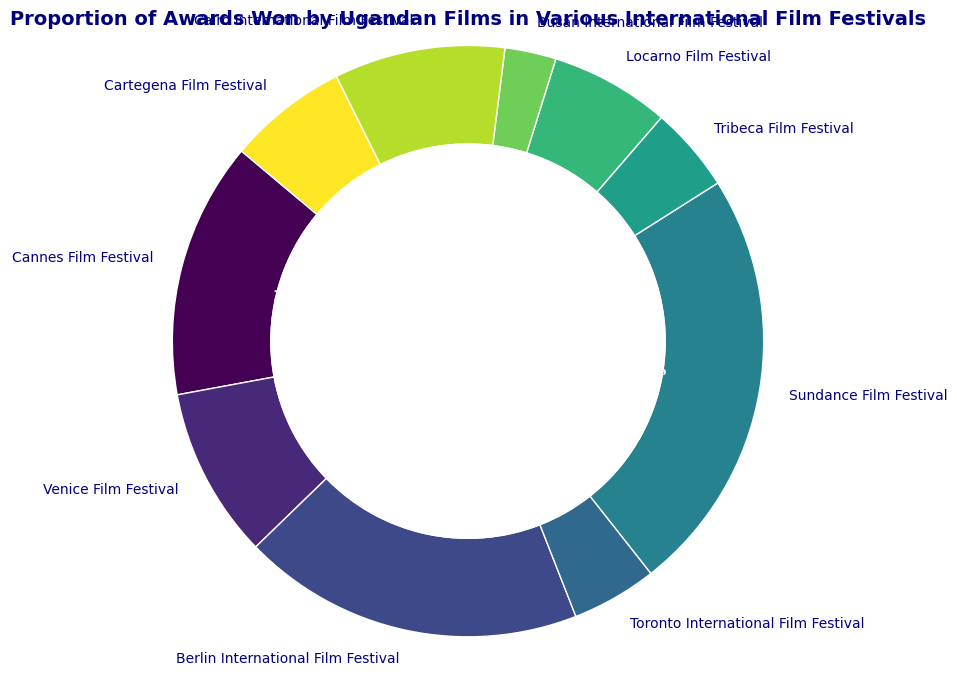Which film festival has the highest proportion of awards won by Ugandan films? By observing the ring chart, the largest segment in size corresponds to the film festival with the highest proportion of awards won.
Answer: Sundance Film Festival What is the combined proportion of awards won at the Berlin International Film Festival and Cannes Film Festival? From the ring chart, Berlin International Film Festival has a proportion of 20% and Cannes Film Festival has 15%. Adding these together gives 20% + 15% = 35%.
Answer: 35% Which two film festivals have equal proportions of awards won by Ugandan films? The ring chart shows that both Toronto International Film Festival and Tribeca Film Festival have the same size segment, indicating equal proportions of awards won. Both are 5%.
Answer: Toronto International Film Festival and Tribeca Film Festival How does the proportion of awards won at the Venice Film Festival compare to that at the Cairo International Film Festival? By comparing the sizes of the segments, the Venice Film Festival has a 10% proportion while the Cairo International Film Festival also has a 10% proportion, indicating they are equal.
Answer: Equal What is the difference in the proportion of awards won between the festival with the highest proportion and the lowest? The highest proportion is at the Sundance Film Festival (25%) and the lowest is at the Busan International Film Festival (3%). The difference is 25% - 3% = 22%.
Answer: 22% Which segment is colored orange? The ring chart uses colors to distinguish segments. By identifying the color orange in the chart, we see it corresponds to Locarno Film Festival.
Answer: Locarno Film Festival What is the average proportion of awards won by Ugandan films across all festivals shown? To find the average, add all proportions: 15% + 10% + 20% + 5% + 25% + 5% + 7% + 3% + 10% + 7% = 107%. Then divide by the number of festivals (10). 107% / 10 = 10.7%.
Answer: 10.7% Which festivals have proportions above the average proportion of awards won? The average proportion is 10.7%. The festivals above this average are Berlin International Film Festival (20%) and Sundance Film Festival (25%).
Answer: Berlin International Film Festival and Sundance Film Festival What is the combined proportion of awards won by Ugandan films in Locarno Film Festival, Busan International Film Festival, and Cairo International Film Festival? Locarno has 7%, Busan has 3%, and Cairo has 10%. Adding these gives 7% + 3% + 10% = 20%.
Answer: 20% Which festival has a segment colored blue in the ring chart? The ring chart uses varying colors, and the segment colored blue represents the Berlin International Film Festival.
Answer: Berlin International Film Festival 